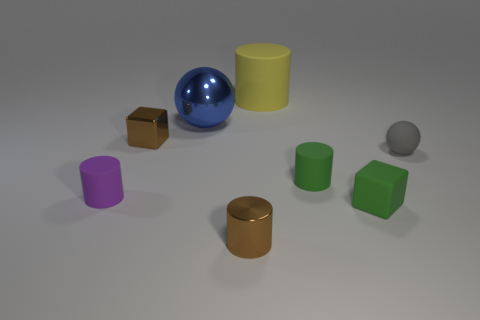There is a small green matte object in front of the tiny rubber thing that is on the left side of the brown metal thing that is to the left of the shiny sphere; what shape is it?
Keep it short and to the point. Cube. What number of big yellow cylinders have the same material as the tiny green cylinder?
Give a very brief answer. 1. There is a brown block that is in front of the blue shiny ball; how many large balls are in front of it?
Give a very brief answer. 0. There is a block that is right of the big blue ball; does it have the same color as the cylinder on the right side of the yellow cylinder?
Provide a succinct answer. Yes. The object that is both behind the tiny brown metallic block and on the left side of the big yellow cylinder has what shape?
Ensure brevity in your answer.  Sphere. Are there any green things that have the same shape as the small purple object?
Your response must be concise. Yes. There is a purple matte thing that is the same size as the rubber cube; what is its shape?
Your response must be concise. Cylinder. What is the large blue sphere made of?
Give a very brief answer. Metal. There is a brown thing that is to the right of the small brown metallic object on the left side of the brown cylinder in front of the big ball; how big is it?
Ensure brevity in your answer.  Small. There is a object that is the same color as the matte cube; what material is it?
Offer a terse response. Rubber. 